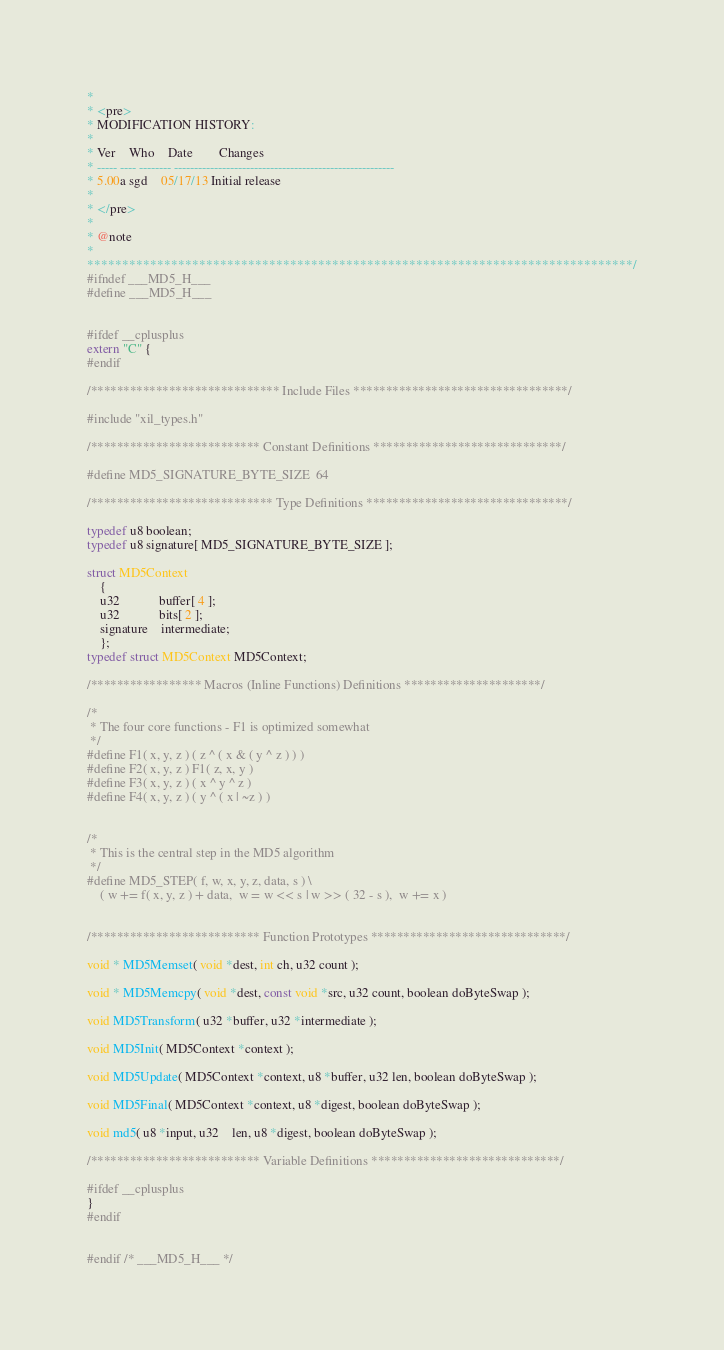Convert code to text. <code><loc_0><loc_0><loc_500><loc_500><_C_>*
* <pre>
* MODIFICATION HISTORY:
*
* Ver	Who	Date		Changes
* ----- ---- -------- -------------------------------------------------------
* 5.00a sgd	05/17/13 Initial release
*
* </pre>
*
* @note
*
******************************************************************************/
#ifndef ___MD5_H___
#define ___MD5_H___


#ifdef __cplusplus
extern "C" {
#endif

/***************************** Include Files *********************************/

#include "xil_types.h"

/************************** Constant Definitions *****************************/

#define MD5_SIGNATURE_BYTE_SIZE	64

/**************************** Type Definitions *******************************/

typedef u8 boolean;
typedef u8 signature[ MD5_SIGNATURE_BYTE_SIZE ];

struct MD5Context
	{
	u32			buffer[ 4 ];
	u32			bits[ 2 ];
	signature	intermediate;
	};
typedef struct MD5Context MD5Context;

/***************** Macros (Inline Functions) Definitions *********************/

/*
 * The four core functions - F1 is optimized somewhat
 */
#define F1( x, y, z ) ( z ^ ( x & ( y ^ z ) ) )
#define F2( x, y, z ) F1( z, x, y )
#define F3( x, y, z ) ( x ^ y ^ z )
#define F4( x, y, z ) ( y ^ ( x | ~z ) )


/*
 * This is the central step in the MD5 algorithm
 */
#define MD5_STEP( f, w, x, y, z, data, s ) \
	( w += f( x, y, z ) + data,  w = w << s | w >> ( 32 - s ),  w += x )


/************************** Function Prototypes ******************************/

void * MD5Memset( void *dest, int ch, u32 count );

void * MD5Memcpy( void *dest, const void *src, u32 count, boolean doByteSwap );

void MD5Transform( u32 *buffer, u32 *intermediate );

void MD5Init( MD5Context *context );

void MD5Update( MD5Context *context, u8 *buffer, u32 len, boolean doByteSwap );

void MD5Final( MD5Context *context, u8 *digest, boolean doByteSwap );

void md5( u8 *input, u32	len, u8 *digest, boolean doByteSwap );

/************************** Variable Definitions *****************************/

#ifdef __cplusplus
}
#endif


#endif /* ___MD5_H___ */
</code> 